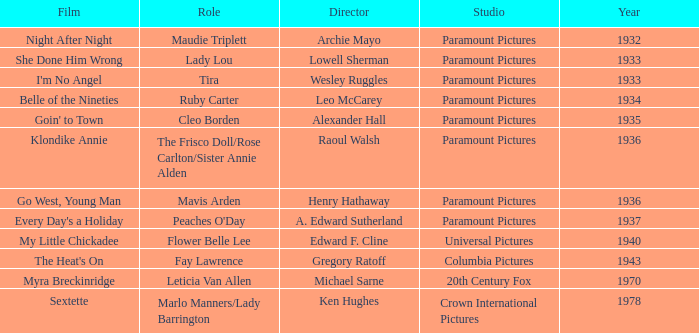What is the Year of the Film Belle of the Nineties? 1934.0. 